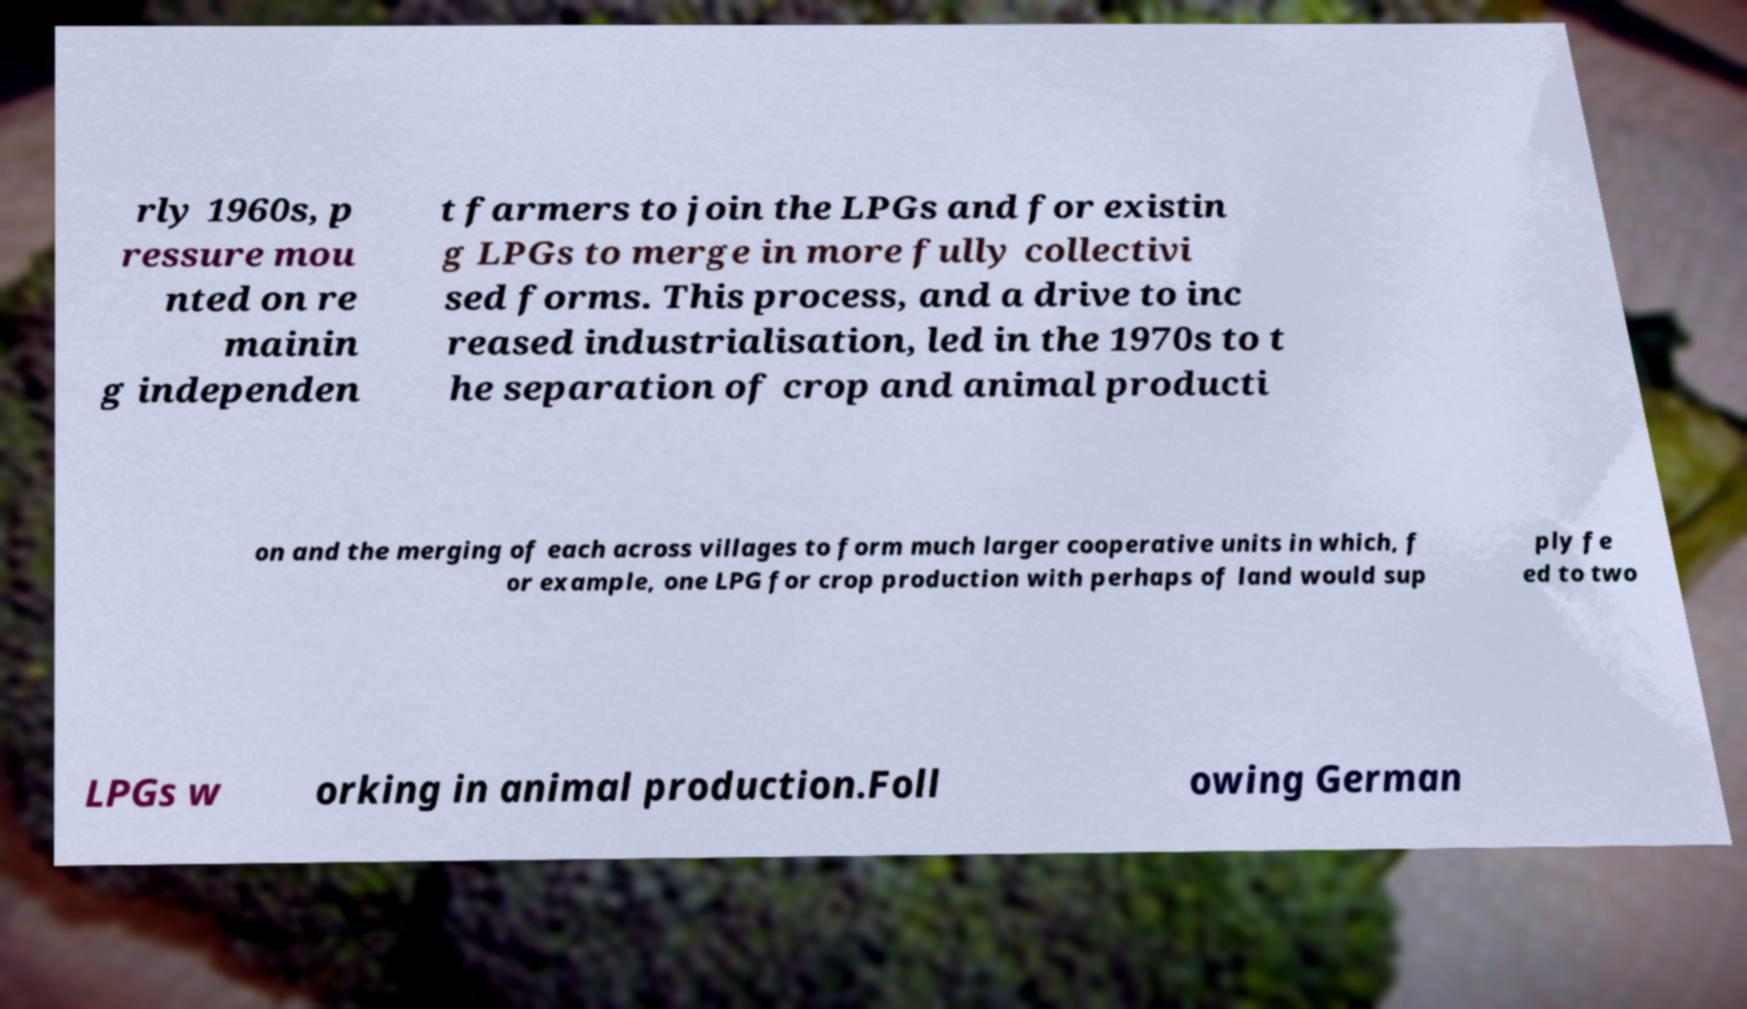Could you extract and type out the text from this image? rly 1960s, p ressure mou nted on re mainin g independen t farmers to join the LPGs and for existin g LPGs to merge in more fully collectivi sed forms. This process, and a drive to inc reased industrialisation, led in the 1970s to t he separation of crop and animal producti on and the merging of each across villages to form much larger cooperative units in which, f or example, one LPG for crop production with perhaps of land would sup ply fe ed to two LPGs w orking in animal production.Foll owing German 